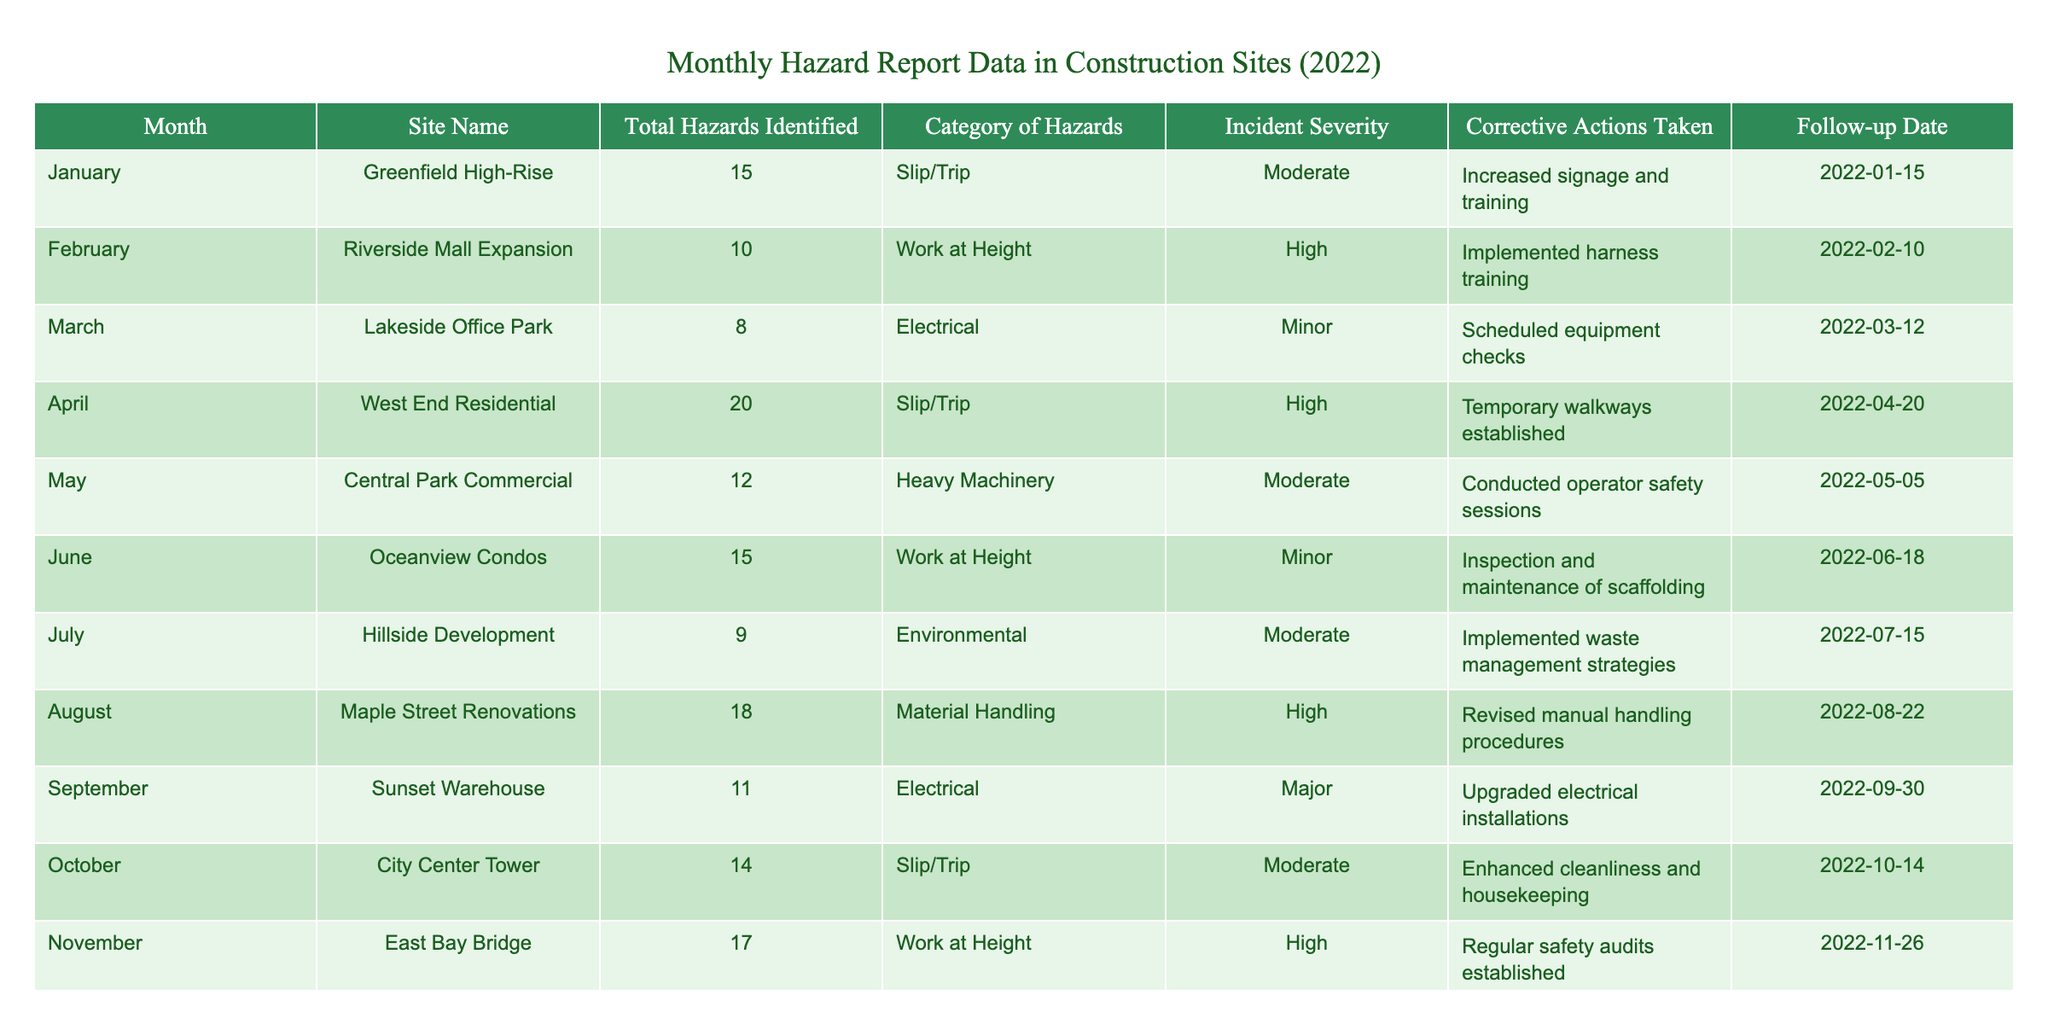What month had the highest number of total hazards identified? To find the month with the highest number, we need to look at the "Total Hazards Identified" column and find the maximum value. The maximum is 20, which appears in April. Thus, April has the highest number of hazards identified.
Answer: April How many corrective actions were taken for the high severity incidents? We identify high severity incidents by checking the "Incident Severity" column for the value "High". In total, there are three instances (February, April, and August), and we count one corrective action taken for each high severity incident, leading to a total of three corrective actions in total.
Answer: 3 What is the average number of total hazards identified across all months? We sum the total hazards identified for all months (15 + 10 + 8 + 20 + 12 + 15 + 9 + 18 + 11 + 14 + 17 + 10 =  15 + 10 + 8 + 20 + 12 + 15 + 9 + 18 + 11 + 14 + 17 + 10 =  16.5) and then divide this sum (165) by the number of months (12). This results in an average of 13.75 hazards identified per month.
Answer: 13.75 Was there any month with a total hazards identified count greater than 15? A count greater than 15 can be identified by examining the "Total Hazards Identified" column. The months with counts greater than 15 are January, April, August, and November. Therefore, the answer is yes.
Answer: Yes What corrective actions were taken in March, and were they effective? In March, the corrective action taken was to schedule equipment checks for minor electrical hazards. To determine effectiveness, we compare the incident severity before and after March in the same category. Since there were no high-severity incidents recorded in March, we conclude this action may have contributed to prevent any severe incidents later on.
Answer: Scheduled equipment checks, potentially effective 